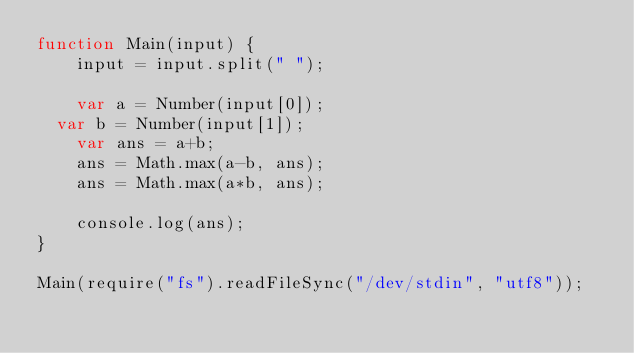Convert code to text. <code><loc_0><loc_0><loc_500><loc_500><_JavaScript_>function Main(input) {
    input = input.split(" ");
    
  	var a = Number(input[0]);
	var b = Number(input[1]);
    var ans = a+b;
  	ans = Math.max(a-b, ans);
  	ans = Math.max(a*b, ans);
  
    console.log(ans);
}

Main(require("fs").readFileSync("/dev/stdin", "utf8"));
</code> 